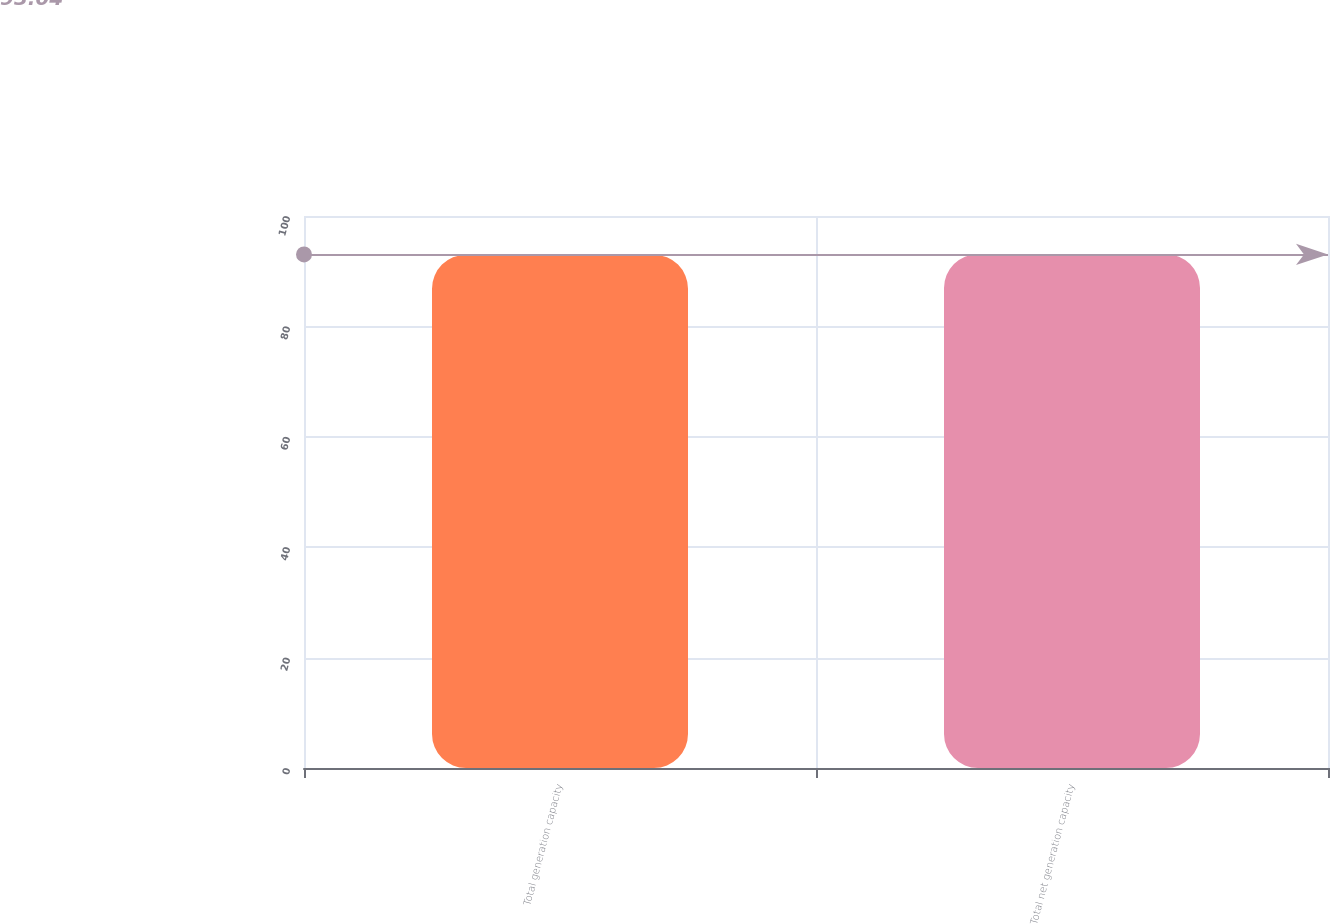Convert chart to OTSL. <chart><loc_0><loc_0><loc_500><loc_500><bar_chart><fcel>Total generation capacity<fcel>Total net generation capacity<nl><fcel>93<fcel>93.1<nl></chart> 